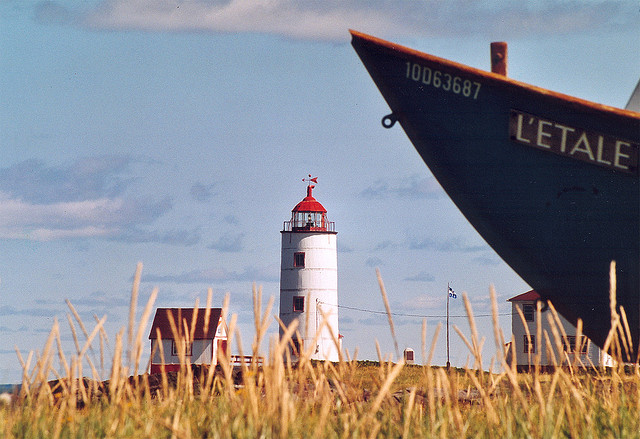Identify and read out the text in this image. TOD63687 L'ETALE 